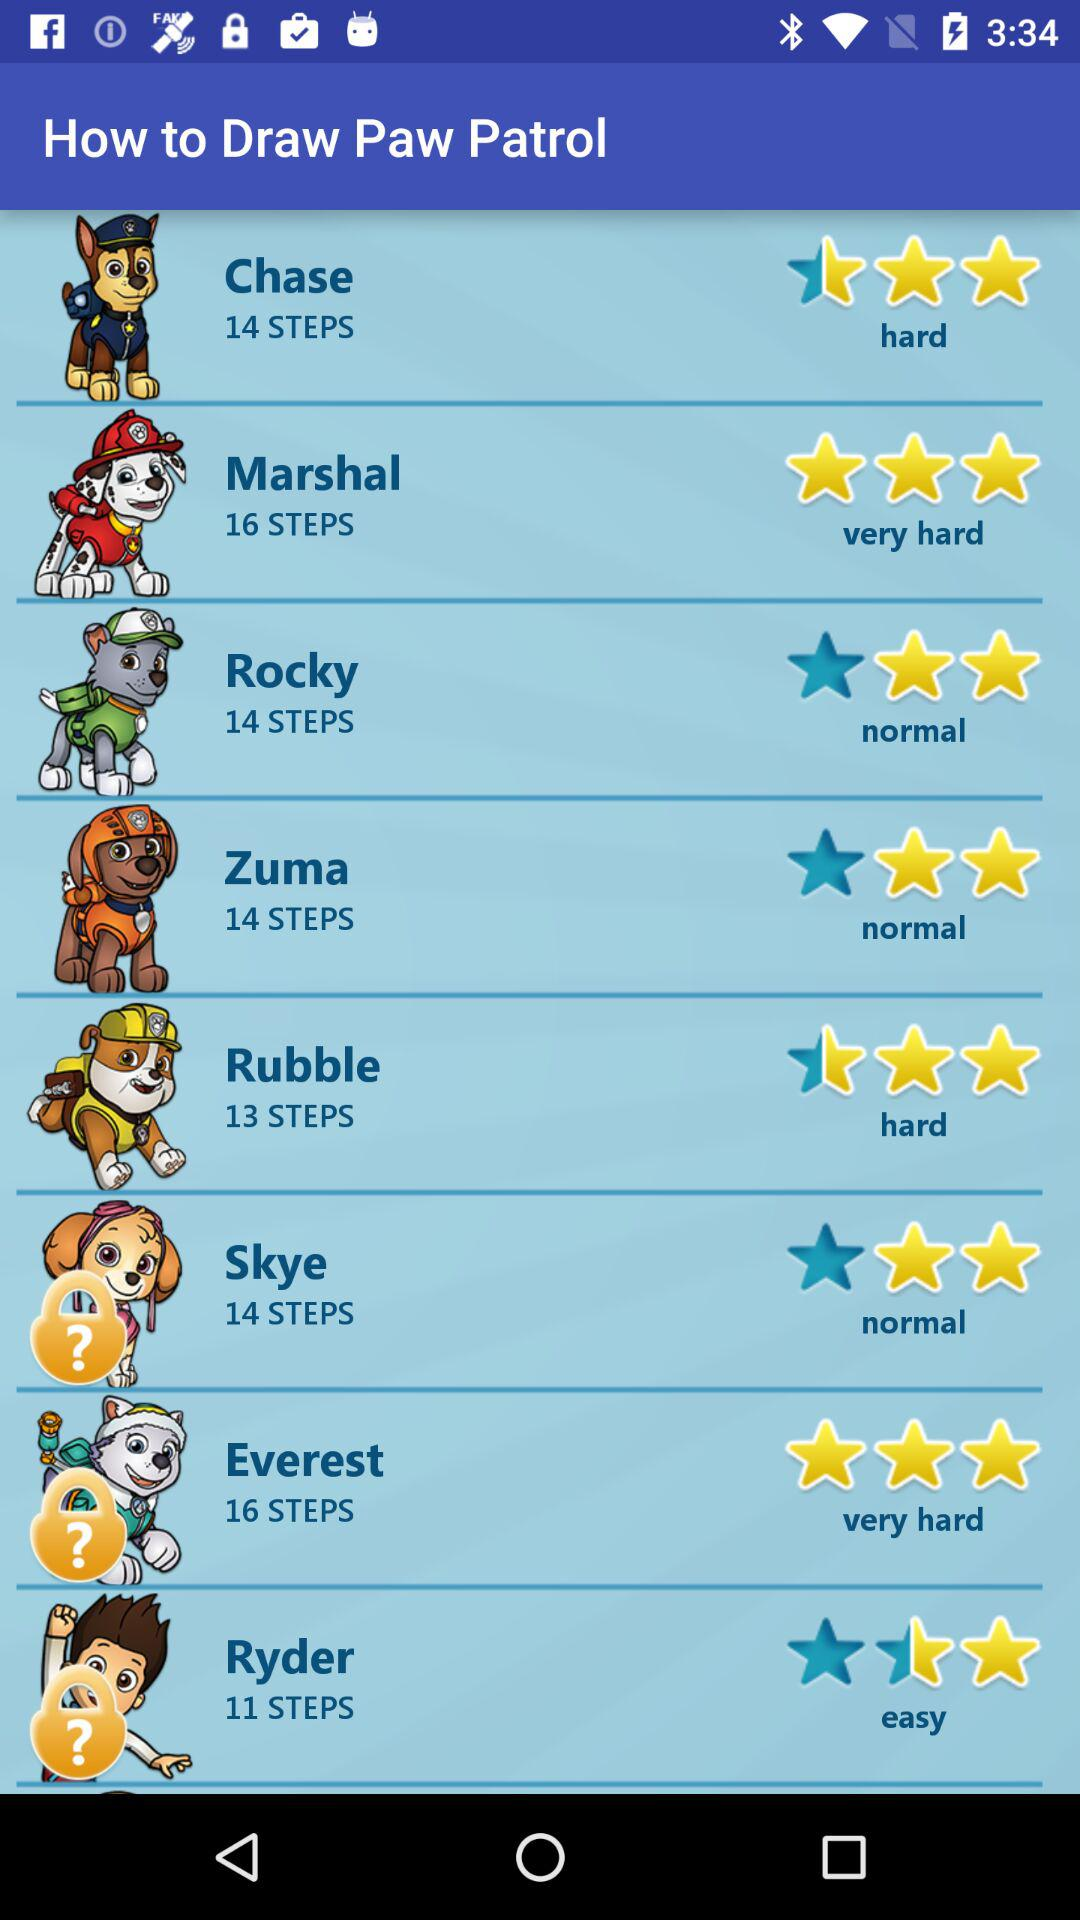How many more steps are there to draw Skye than to draw Marshall?
Answer the question using a single word or phrase. 2 